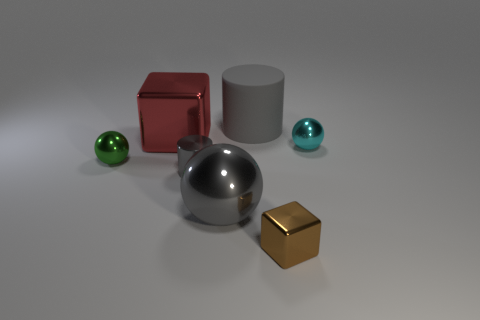There is a large gray shiny thing; does it have the same shape as the large gray object that is behind the small cyan metal sphere?
Keep it short and to the point. No. How many things are metal things right of the small gray object or cubes?
Provide a short and direct response. 4. Is there anything else that has the same material as the small brown cube?
Offer a very short reply. Yes. What number of metallic things are both behind the tiny metallic block and on the left side of the cyan sphere?
Provide a succinct answer. 4. How many objects are either tiny things that are right of the gray ball or shiny blocks that are right of the large cube?
Offer a very short reply. 2. What number of other objects are the same shape as the green shiny thing?
Make the answer very short. 2. There is a cylinder to the left of the big rubber thing; is it the same color as the big cube?
Offer a very short reply. No. What number of other things are there of the same size as the cyan metallic sphere?
Ensure brevity in your answer.  3. Does the brown block have the same material as the big cylinder?
Offer a very short reply. No. There is a metallic cube that is behind the metallic block in front of the small green ball; what is its color?
Give a very brief answer. Red. 